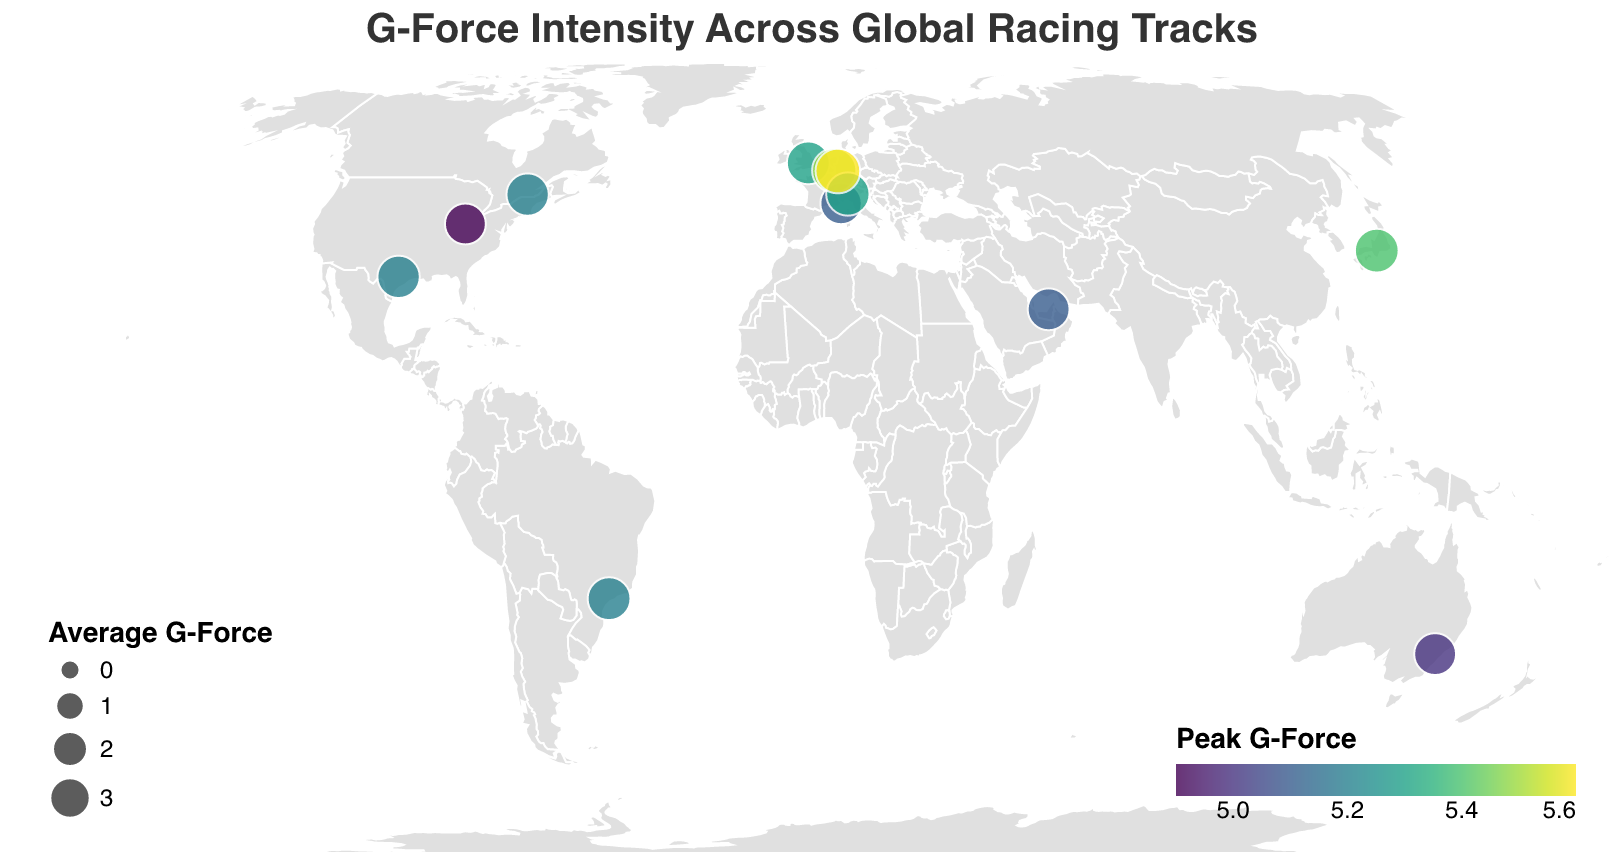What's the title of the heatmap? The title is displayed at the top of the plot, which reads "G-Force Intensity Across Global Racing Tracks".
Answer: G-Force Intensity Across Global Racing Tracks How is the color of the circles determined in the plot? The color of the circles indicates the Peak G-Force experienced at each track, with a gradient from lower to higher Peak G-Force values.
Answer: Peak G-Force What is the Peak G-Force at Spa-Francorchamps? To find the Peak G-Force at Spa-Francorchamps, hover over or locate the circle representing this track. The tooltip displays detailed values including Peak G-Force.
Answer: 5.5 Which track has the lowest Peak G-Force and what is its value? Locate the circle with the lightest color shade or hover over each circle to find the track with the lowest Peak G-Force. The tooltip or color legend shows it corresponds to Indianapolis Motor Speedway.
Answer: Indianapolis Motor Speedway, 4.9 Which track experiences the highest Average G-Force? Look for the largest circle, as circle size represents Average G-Force. Hover over this circle to confirm its name and value.
Answer: Nürburgring, 3.9 Compare the Peak G-Force of Monza Circuit and Suzuka Circuit. Which is higher? Find and compare the color shades of the circles representing Monza Circuit and Suzuka Circuit, or hover over them to check the Peak G-Force values shown in the tooltip.
Answer: Suzuka Circuit By how much is the Peak G-Force of Nürburgring higher than that of Yas Marina Circuit? Hover over the circles representing Nürburgring and Yas Marina Circuit to obtain Peak G-Force values, then calculate the difference (5.6 - 5.1).
Answer: 0.5 Which track is closest to having an Average G-Force of 3.5? Check each circle’s tooltip for the Average G-Force values and find the one closest to 3.5. Several tracks such as Silverstone Circuit and Interlagos Circuit may be close, but exact values are required.
Answer: Silverstone Circuit or Interlagos Circuit, 3.5 Are there any tracks in the southern hemisphere, and what are their Peak G-Force values? Identify tracks located in the southern hemisphere by their latitude values (negative latitude), then check their Peak G-Force values.
Answer: Mount Panorama Circuit (5.0), Interlagos Circuit (5.2) Which continent has the most racing tracks represented on this plot? Observe the geographic distribution of the circles and count the number of tracks per continent.
Answer: Europe 